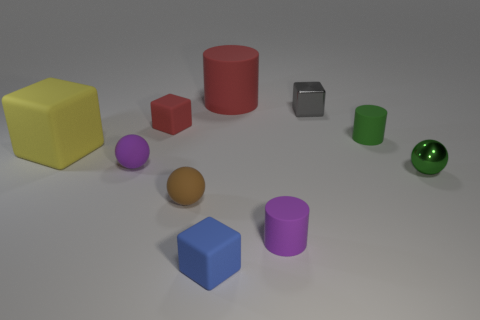Subtract 1 blocks. How many blocks are left? 3 Subtract all blocks. How many objects are left? 6 Add 5 blue matte objects. How many blue matte objects are left? 6 Add 1 large red matte things. How many large red matte things exist? 2 Subtract 1 red cubes. How many objects are left? 9 Subtract all tiny gray cubes. Subtract all red cylinders. How many objects are left? 8 